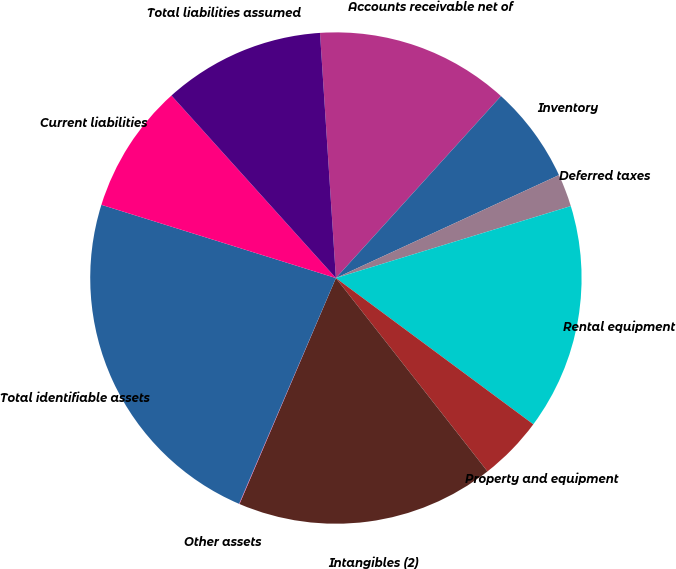<chart> <loc_0><loc_0><loc_500><loc_500><pie_chart><fcel>Accounts receivable net of<fcel>Inventory<fcel>Deferred taxes<fcel>Rental equipment<fcel>Property and equipment<fcel>Intangibles (2)<fcel>Other assets<fcel>Total identifiable assets<fcel>Current liabilities<fcel>Total liabilities assumed<nl><fcel>12.76%<fcel>6.39%<fcel>2.15%<fcel>14.88%<fcel>4.27%<fcel>17.0%<fcel>0.03%<fcel>23.37%<fcel>8.51%<fcel>10.64%<nl></chart> 